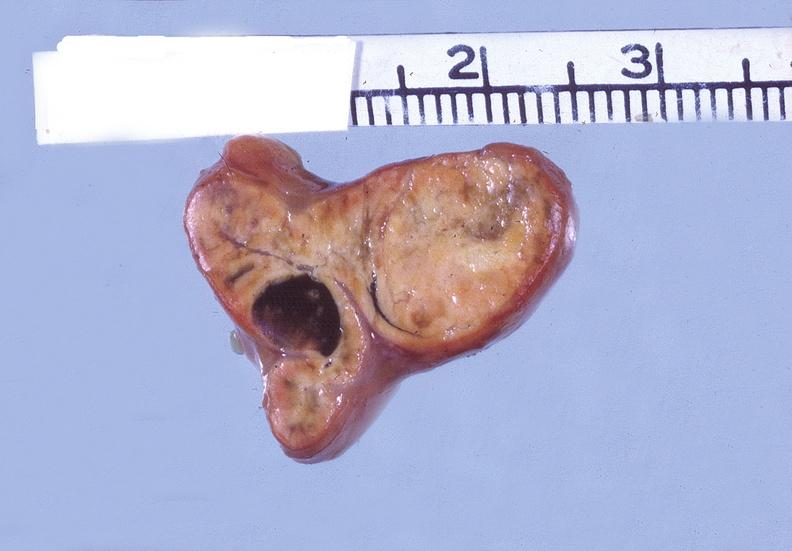does quite good liver show adrenal, cortical adenoma?
Answer the question using a single word or phrase. No 